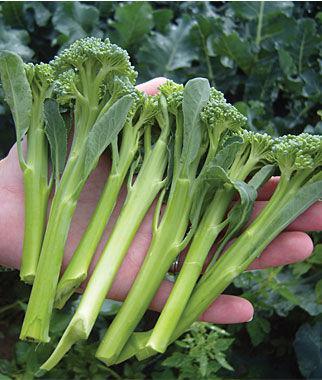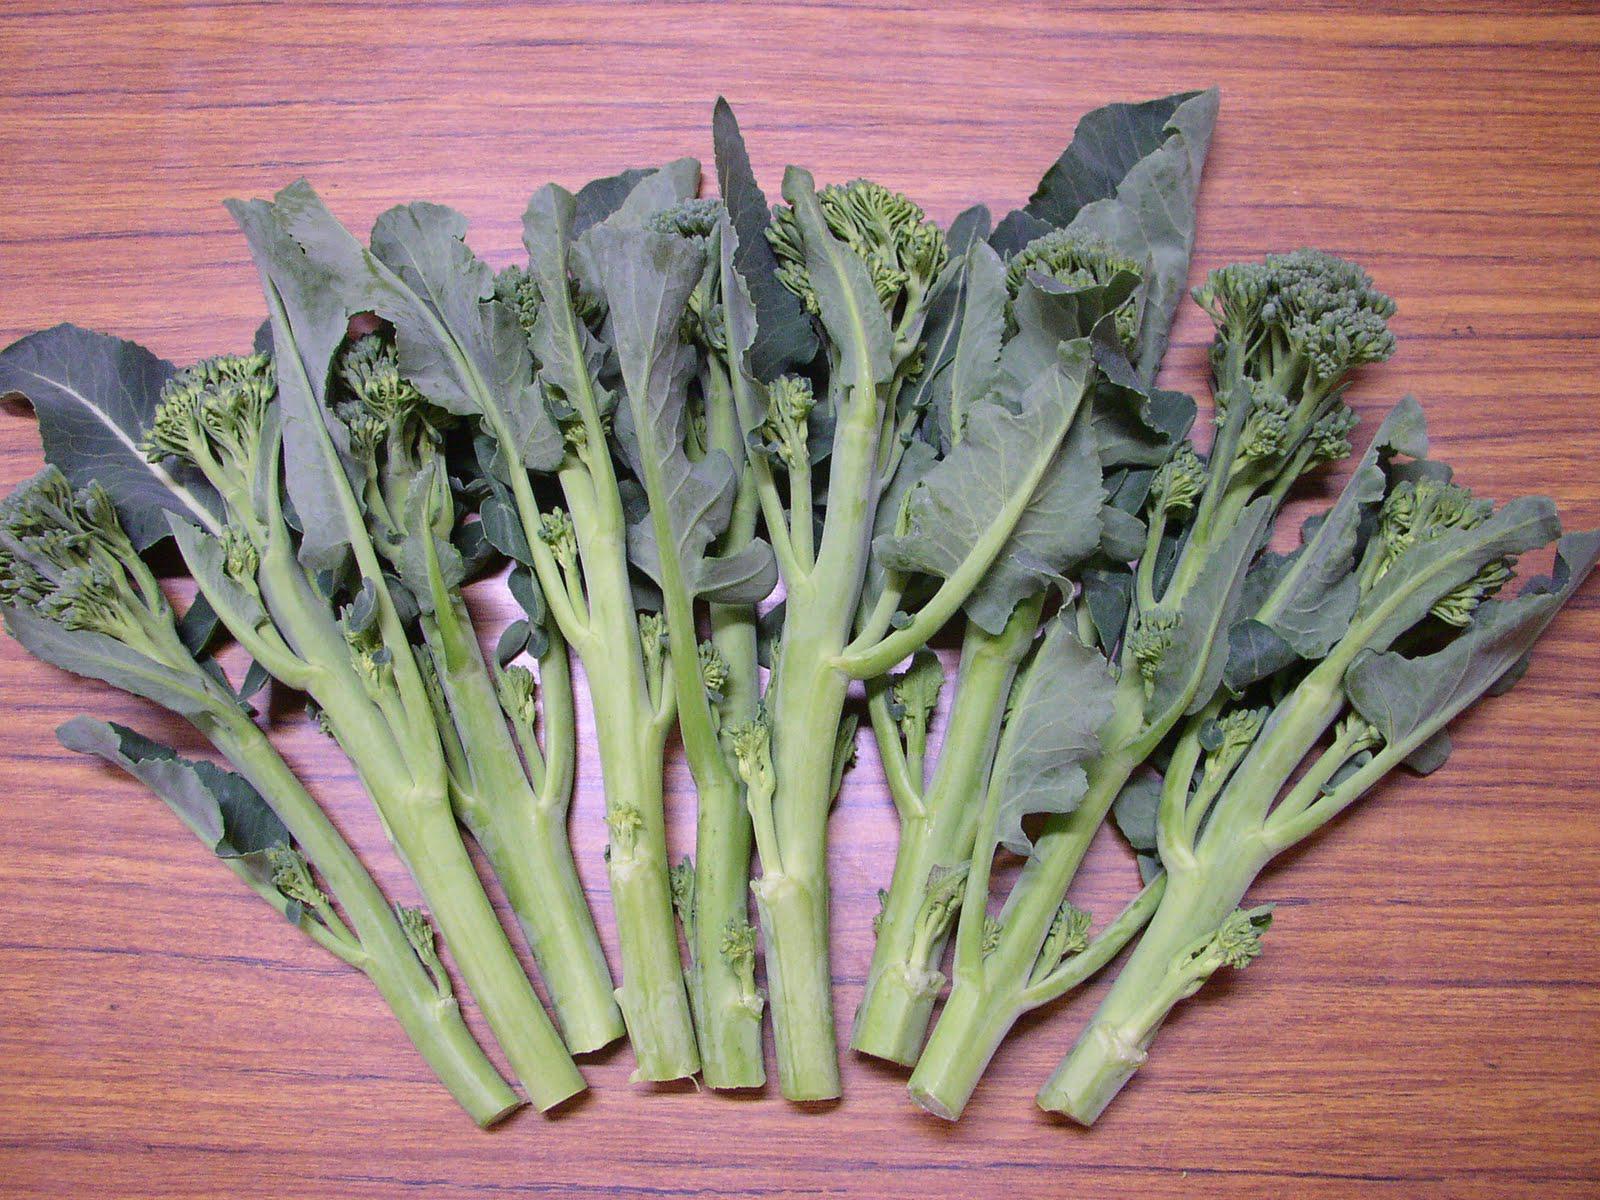The first image is the image on the left, the second image is the image on the right. Given the left and right images, does the statement "There is broccoli on a table." hold true? Answer yes or no. Yes. The first image is the image on the left, the second image is the image on the right. For the images shown, is this caption "The right image shows broccoli on a wooden surface." true? Answer yes or no. Yes. 